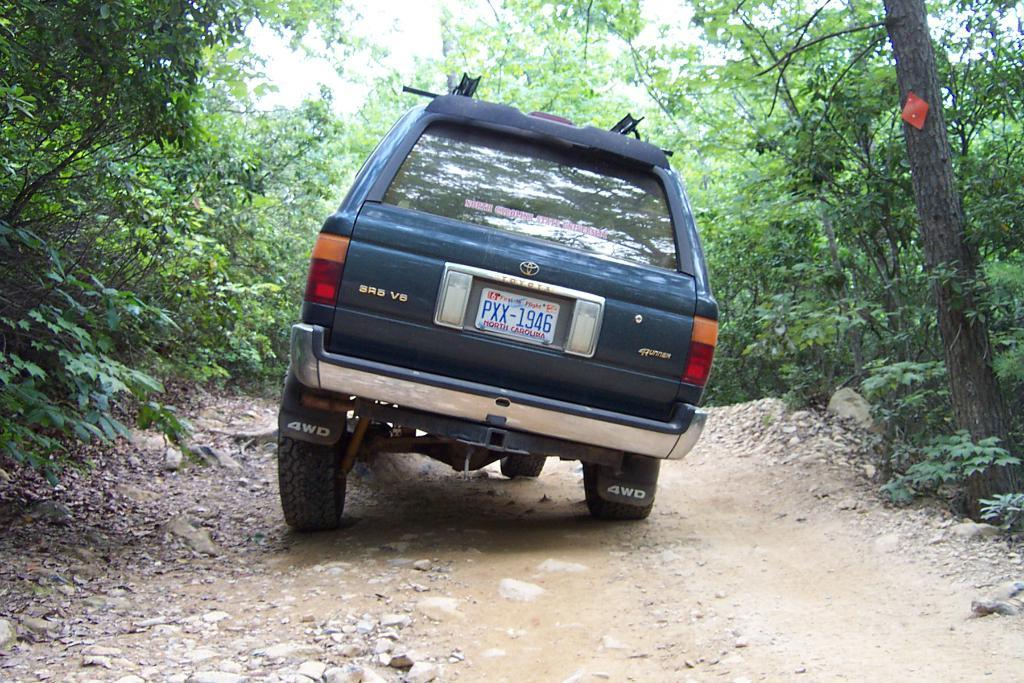What is the main feature of the image? There is a road in the image. What is present on the road? There is a vehicle on the road. What can be seen beside the road? There are trees visible beside the road. What channel is the vehicle tuned to in the image? There is no indication of a television or channel in the image; it features a road, a vehicle, and trees. 